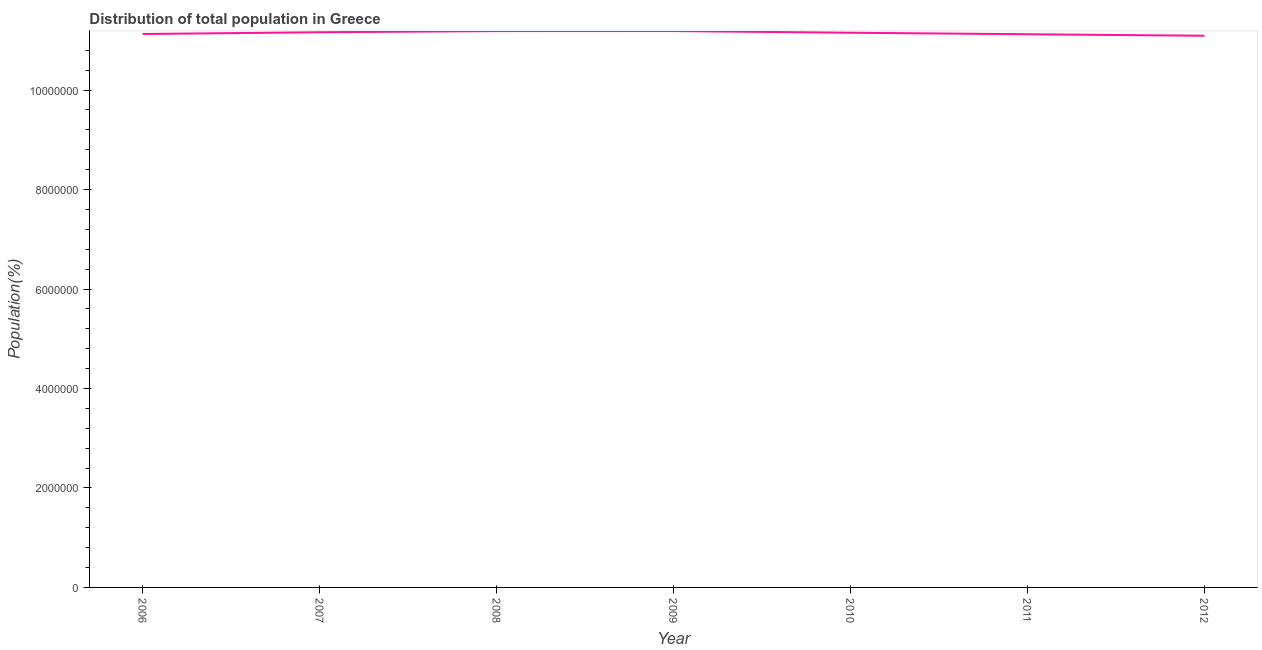What is the population in 2012?
Ensure brevity in your answer.  1.11e+07. Across all years, what is the maximum population?
Make the answer very short. 1.12e+07. Across all years, what is the minimum population?
Provide a succinct answer. 1.11e+07. In which year was the population maximum?
Ensure brevity in your answer.  2009. What is the sum of the population?
Ensure brevity in your answer.  7.80e+07. What is the difference between the population in 2006 and 2008?
Provide a short and direct response. -5.85e+04. What is the average population per year?
Offer a very short reply. 1.11e+07. What is the median population?
Provide a succinct answer. 1.12e+07. Do a majority of the years between 2006 and 2011 (inclusive) have population greater than 2000000 %?
Your answer should be compact. Yes. What is the ratio of the population in 2011 to that in 2012?
Your response must be concise. 1. Is the difference between the population in 2009 and 2011 greater than the difference between any two years?
Offer a very short reply. No. What is the difference between the highest and the second highest population?
Offer a terse response. 646. What is the difference between the highest and the lowest population?
Give a very brief answer. 9.43e+04. In how many years, is the population greater than the average population taken over all years?
Offer a terse response. 4. Does the population monotonically increase over the years?
Your response must be concise. No. How many lines are there?
Your answer should be compact. 1. Does the graph contain any zero values?
Your answer should be very brief. No. Does the graph contain grids?
Your answer should be compact. No. What is the title of the graph?
Keep it short and to the point. Distribution of total population in Greece . What is the label or title of the X-axis?
Give a very brief answer. Year. What is the label or title of the Y-axis?
Give a very brief answer. Population(%). What is the Population(%) in 2006?
Provide a short and direct response. 1.11e+07. What is the Population(%) of 2007?
Your answer should be compact. 1.12e+07. What is the Population(%) of 2008?
Your response must be concise. 1.12e+07. What is the Population(%) of 2009?
Keep it short and to the point. 1.12e+07. What is the Population(%) of 2010?
Make the answer very short. 1.12e+07. What is the Population(%) of 2011?
Offer a terse response. 1.11e+07. What is the Population(%) in 2012?
Keep it short and to the point. 1.11e+07. What is the difference between the Population(%) in 2006 and 2007?
Provide a short and direct response. -3.51e+04. What is the difference between the Population(%) in 2006 and 2008?
Your answer should be very brief. -5.85e+04. What is the difference between the Population(%) in 2006 and 2009?
Make the answer very short. -5.91e+04. What is the difference between the Population(%) in 2006 and 2010?
Provide a short and direct response. -2.55e+04. What is the difference between the Population(%) in 2006 and 2011?
Your answer should be compact. 4734. What is the difference between the Population(%) in 2006 and 2012?
Keep it short and to the point. 3.52e+04. What is the difference between the Population(%) in 2007 and 2008?
Make the answer very short. -2.34e+04. What is the difference between the Population(%) in 2007 and 2009?
Your answer should be very brief. -2.41e+04. What is the difference between the Population(%) in 2007 and 2010?
Your answer should be very brief. 9548. What is the difference between the Population(%) in 2007 and 2011?
Provide a short and direct response. 3.98e+04. What is the difference between the Population(%) in 2007 and 2012?
Ensure brevity in your answer.  7.02e+04. What is the difference between the Population(%) in 2008 and 2009?
Your answer should be very brief. -646. What is the difference between the Population(%) in 2008 and 2010?
Keep it short and to the point. 3.30e+04. What is the difference between the Population(%) in 2008 and 2011?
Provide a short and direct response. 6.32e+04. What is the difference between the Population(%) in 2008 and 2012?
Offer a terse response. 9.37e+04. What is the difference between the Population(%) in 2009 and 2010?
Provide a short and direct response. 3.36e+04. What is the difference between the Population(%) in 2009 and 2011?
Make the answer very short. 6.39e+04. What is the difference between the Population(%) in 2009 and 2012?
Give a very brief answer. 9.43e+04. What is the difference between the Population(%) in 2010 and 2011?
Your response must be concise. 3.02e+04. What is the difference between the Population(%) in 2010 and 2012?
Keep it short and to the point. 6.07e+04. What is the difference between the Population(%) in 2011 and 2012?
Your response must be concise. 3.04e+04. What is the ratio of the Population(%) in 2006 to that in 2007?
Your answer should be very brief. 1. What is the ratio of the Population(%) in 2006 to that in 2009?
Your answer should be compact. 0.99. What is the ratio of the Population(%) in 2006 to that in 2010?
Ensure brevity in your answer.  1. What is the ratio of the Population(%) in 2006 to that in 2011?
Provide a short and direct response. 1. What is the ratio of the Population(%) in 2007 to that in 2008?
Your answer should be compact. 1. What is the ratio of the Population(%) in 2007 to that in 2009?
Your answer should be very brief. 1. What is the ratio of the Population(%) in 2007 to that in 2011?
Make the answer very short. 1. What is the ratio of the Population(%) in 2007 to that in 2012?
Give a very brief answer. 1.01. What is the ratio of the Population(%) in 2008 to that in 2010?
Give a very brief answer. 1. What is the ratio of the Population(%) in 2008 to that in 2011?
Offer a terse response. 1.01. What is the ratio of the Population(%) in 2008 to that in 2012?
Make the answer very short. 1.01. What is the ratio of the Population(%) in 2009 to that in 2011?
Ensure brevity in your answer.  1.01. What is the ratio of the Population(%) in 2009 to that in 2012?
Your answer should be compact. 1.01. What is the ratio of the Population(%) in 2010 to that in 2011?
Your answer should be very brief. 1. What is the ratio of the Population(%) in 2010 to that in 2012?
Offer a terse response. 1. 